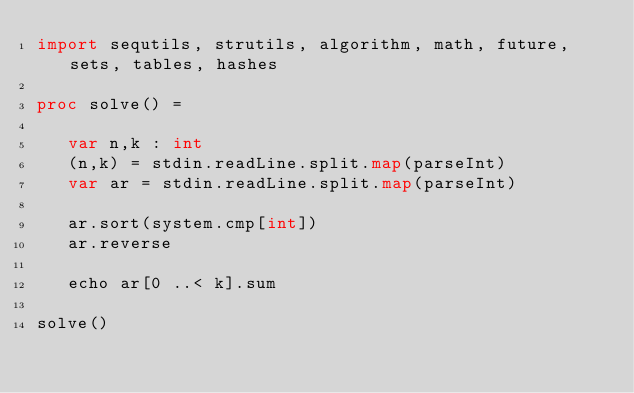<code> <loc_0><loc_0><loc_500><loc_500><_Nim_>import sequtils, strutils, algorithm, math, future, sets, tables, hashes

proc solve() =
   
   var n,k : int
   (n,k) = stdin.readLine.split.map(parseInt)
   var ar = stdin.readLine.split.map(parseInt)

   ar.sort(system.cmp[int])
   ar.reverse
   
   echo ar[0 ..< k].sum

solve()</code> 